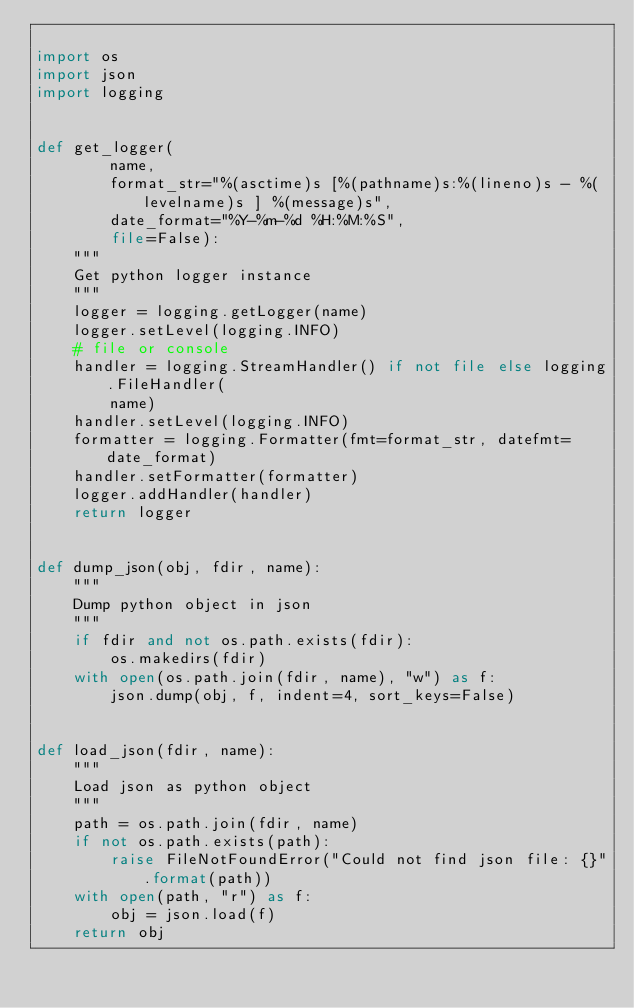Convert code to text. <code><loc_0><loc_0><loc_500><loc_500><_Python_>
import os
import json
import logging


def get_logger(
        name,
        format_str="%(asctime)s [%(pathname)s:%(lineno)s - %(levelname)s ] %(message)s",
        date_format="%Y-%m-%d %H:%M:%S",
        file=False):
    """
    Get python logger instance
    """
    logger = logging.getLogger(name)
    logger.setLevel(logging.INFO)
    # file or console
    handler = logging.StreamHandler() if not file else logging.FileHandler(
        name)
    handler.setLevel(logging.INFO)
    formatter = logging.Formatter(fmt=format_str, datefmt=date_format)
    handler.setFormatter(formatter)
    logger.addHandler(handler)
    return logger


def dump_json(obj, fdir, name):
    """
    Dump python object in json
    """
    if fdir and not os.path.exists(fdir):
        os.makedirs(fdir)
    with open(os.path.join(fdir, name), "w") as f:
        json.dump(obj, f, indent=4, sort_keys=False)


def load_json(fdir, name):
    """
    Load json as python object
    """
    path = os.path.join(fdir, name)
    if not os.path.exists(path):
        raise FileNotFoundError("Could not find json file: {}".format(path))
    with open(path, "r") as f:
        obj = json.load(f)
    return obj</code> 